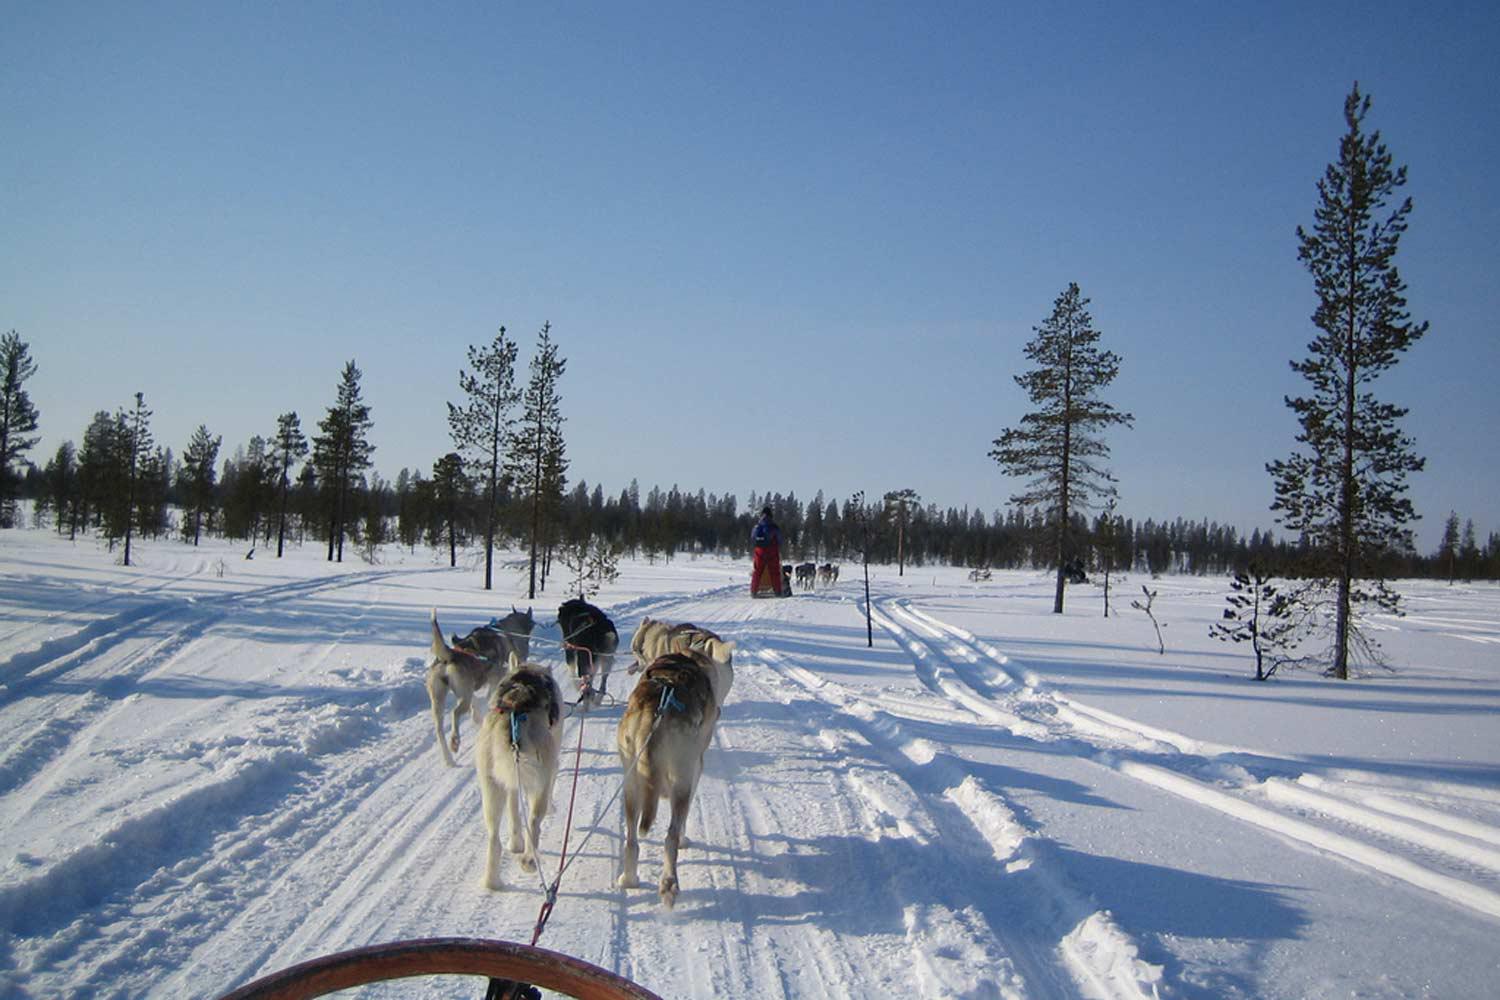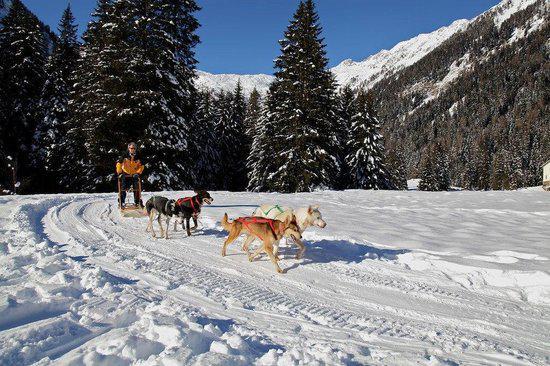The first image is the image on the left, the second image is the image on the right. Analyze the images presented: Is the assertion "The sled teams in the two images are headed in the same direction." valid? Answer yes or no. No. The first image is the image on the left, the second image is the image on the right. Considering the images on both sides, is "There are exactly three dogs pulling the sled in the image on the right" valid? Answer yes or no. No. 